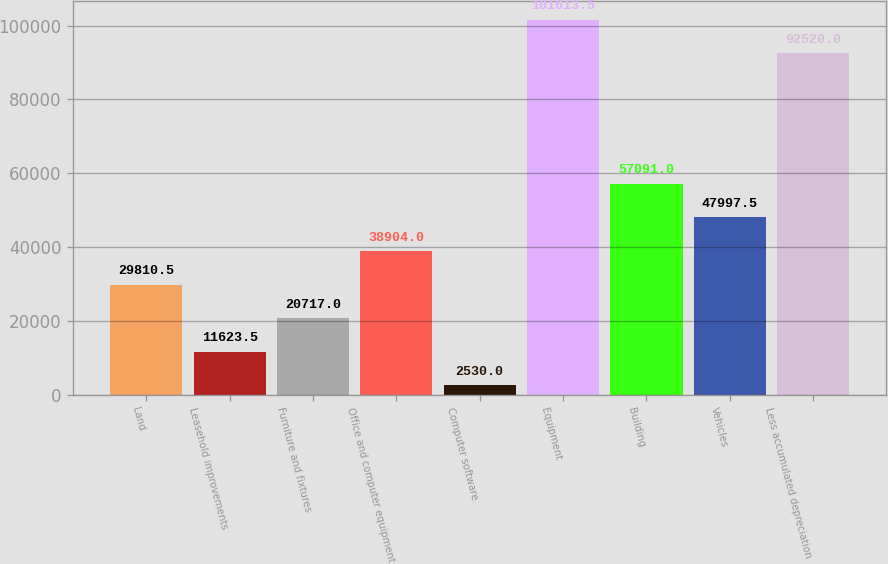<chart> <loc_0><loc_0><loc_500><loc_500><bar_chart><fcel>Land<fcel>Leasehold improvements<fcel>Furniture and fixtures<fcel>Office and computer equipment<fcel>Computer software<fcel>Equipment<fcel>Building<fcel>Vehicles<fcel>Less accumulated depreciation<nl><fcel>29810.5<fcel>11623.5<fcel>20717<fcel>38904<fcel>2530<fcel>101614<fcel>57091<fcel>47997.5<fcel>92520<nl></chart> 